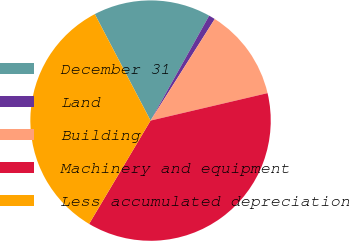Convert chart. <chart><loc_0><loc_0><loc_500><loc_500><pie_chart><fcel>December 31<fcel>Land<fcel>Building<fcel>Machinery and equipment<fcel>Less accumulated depreciation<nl><fcel>15.79%<fcel>0.86%<fcel>12.36%<fcel>37.21%<fcel>33.78%<nl></chart> 